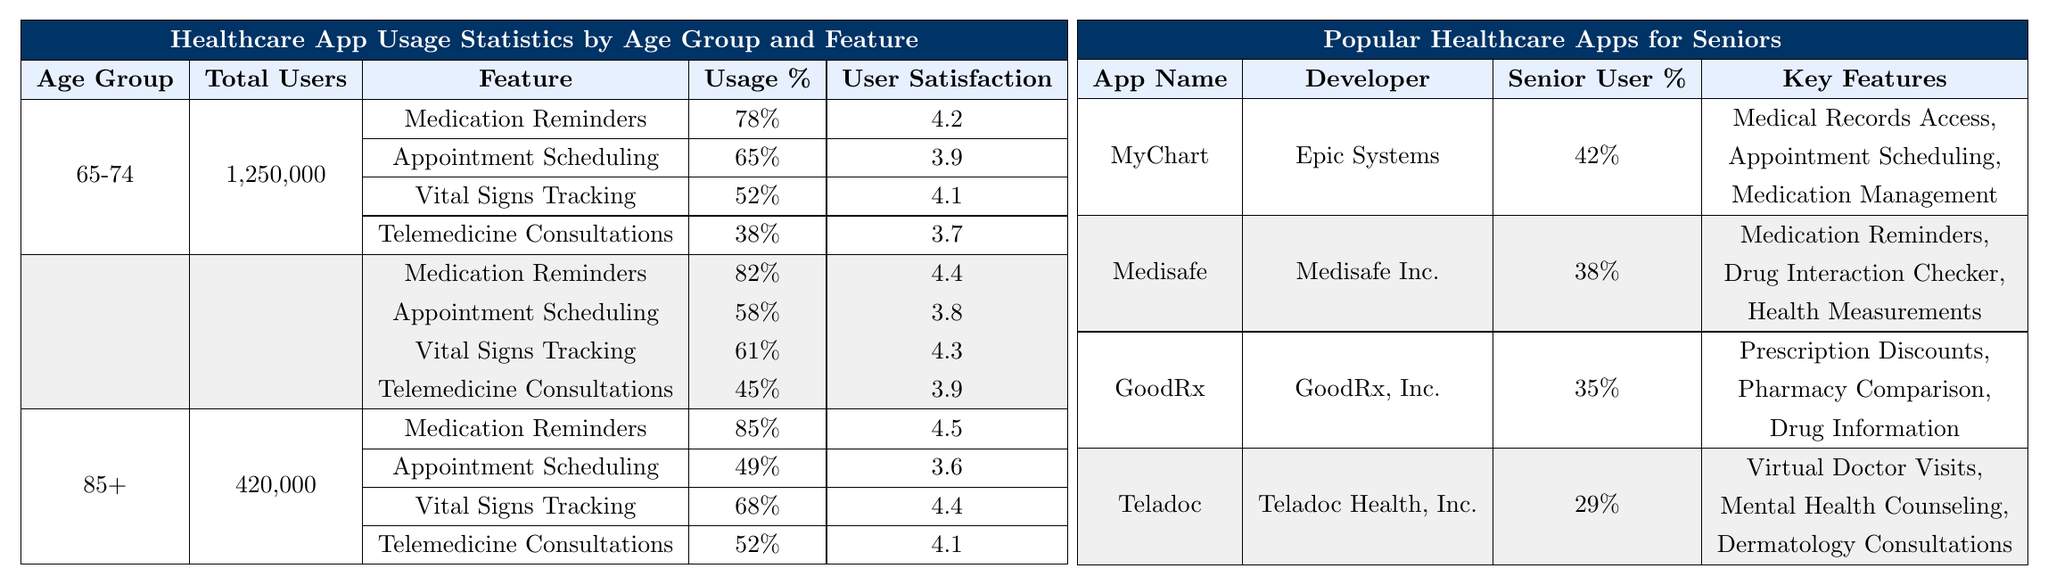What feature has the highest usage percentage among the age group 85+? The table shows that for the age group 85+, the feature "Medication Reminders" has the highest usage percentage at 85%.
Answer: 85% What is the user satisfaction rating for Appointment Scheduling in the 75-84 age group? According to the table, the user satisfaction rating for Appointment Scheduling in the 75-84 age group is 3.8.
Answer: 3.8 How many total users utilize the Telemedicine Consultations feature in the 65-74 age group? In the age group 65-74, there are 1,250,000 total users; the usage percentage for Telemedicine Consultations is 38%, so the total users for this feature is calculated as 1,250,000 * 0.38 = 475,000.
Answer: 475,000 Which age group has the lowest user satisfaction for Appointment Scheduling? The table indicates that the 85+ age group has the lowest user satisfaction for Appointment Scheduling, with a rating of 3.6.
Answer: 3.6 What is the average user satisfaction for the Medication Reminders feature across all age groups? To find the average user satisfaction for Medication Reminders, we take the values: 4.2 (65-74), 4.4 (75-84), and 4.5 (85+). Adding them gives 4.2 + 4.4 + 4.5 = 13.1, and dividing by 3 (the number of age groups) gives an average of 13.1 / 3 ≈ 4.37.
Answer: 4.37 Is the usage percentage for Vital Signs Tracking higher in the 75-84 age group compared to the 65-74 age group? Yes, the usage percentage for Vital Signs Tracking is 61% in the 75-84 age group, while it is 52% in the 65-74 age group.
Answer: Yes What feature recorded the least usage in the 85+ age group? The feature with the least usage in the 85+ age group is "Appointment Scheduling," which has a usage percentage of 49%.
Answer: 49% How many more users are there for Medication Reminders in the 85+ group compared to the 75-84 group? The number of users for Medication Reminders is 85% of 420,000 in the 85+ group, which is 357,000. In the 75-84 group, it is 82% of 980,000, which is 803,600. The difference is 803,600 - 357,000 = 446,600 more users for the 75-84 group.
Answer: 446,600 Which healthcare app has the highest percentage of senior users? The table shows that the healthcare app with the highest percentage of senior users is "MyChart" with 42%.
Answer: MyChart What percentage of users in the 65-74 age group are utilizing Telemedicine Consultations? The table states that in the 65-74 age group, the usage percentage for Telemedicine Consultations is 38%.
Answer: 38% 